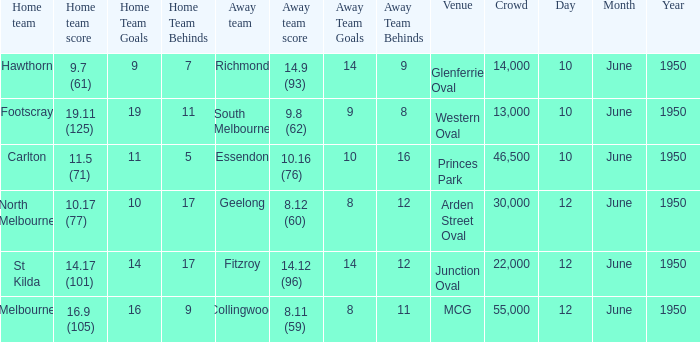Who was the away team when the VFL played at MCG? Collingwood. 